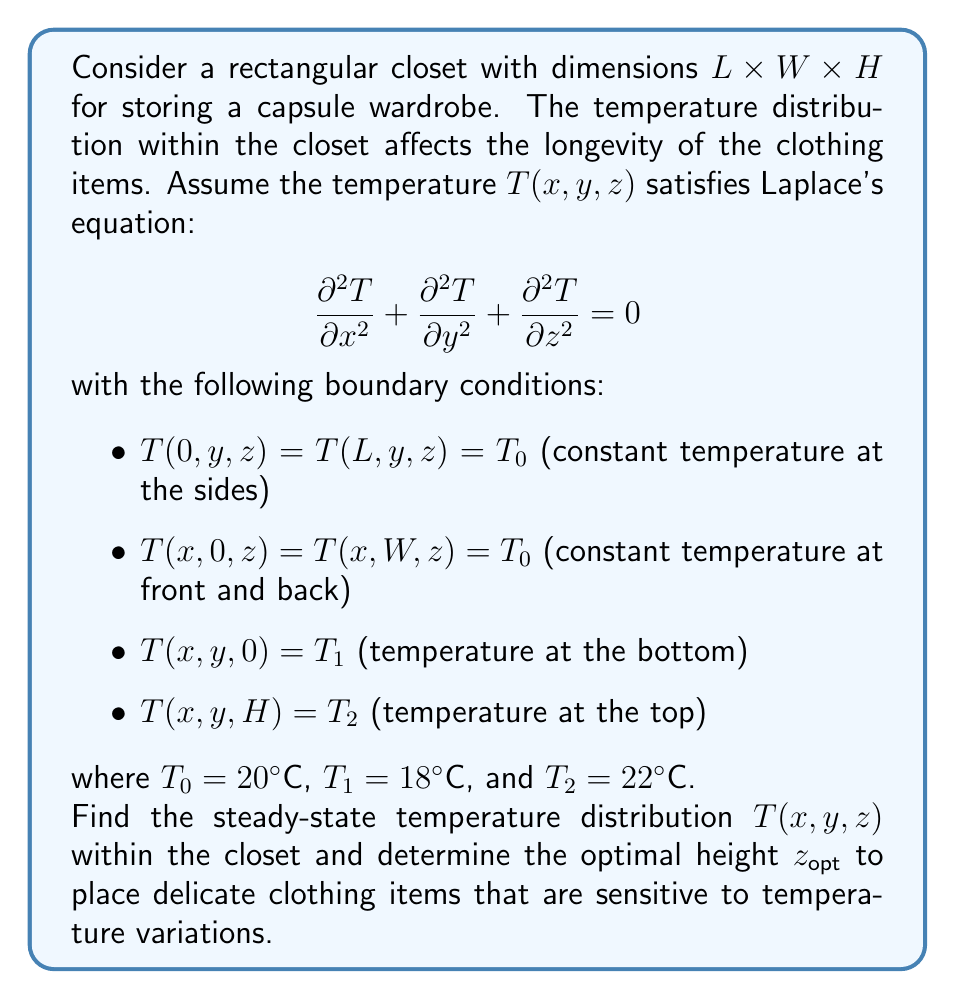Give your solution to this math problem. To solve this problem, we'll follow these steps:

1) The general solution to Laplace's equation in 3D rectangular coordinates is:

   $$T(x,y,z) = \sum_{m=1}^{\infty} \sum_{n=1}^{\infty} [A_{mn} \sinh(\lambda_{mn}z) + B_{mn} \cosh(\lambda_{mn}z)] \sin(\frac{m\pi x}{L}) \sin(\frac{n\pi y}{W})$$

   where $\lambda_{mn} = \pi \sqrt{(\frac{m}{L})^2 + (\frac{n}{W})^2}$

2) The boundary conditions at $x=0$, $x=L$, $y=0$, and $y=W$ are already satisfied by this general solution.

3) To satisfy the boundary conditions at $z=0$ and $z=H$, we need:

   $$T(x,y,0) = T_1 = \sum_{m=1}^{\infty} \sum_{n=1}^{\infty} B_{mn} \sin(\frac{m\pi x}{L}) \sin(\frac{n\pi y}{W})$$

   $$T(x,y,H) = T_2 = \sum_{m=1}^{\infty} \sum_{n=1}^{\infty} [A_{mn} \sinh(\lambda_{mn}H) + B_{mn} \cosh(\lambda_{mn}H)] \sin(\frac{m\pi x}{L}) \sin(\frac{n\pi y}{W})$$

4) Subtracting these equations:

   $$T_2 - T_1 = \sum_{m=1}^{\infty} \sum_{n=1}^{\infty} A_{mn} \sinh(\lambda_{mn}H) \sin(\frac{m\pi x}{L}) \sin(\frac{n\pi y}{W})$$

5) This implies:

   $$A_{mn} = \frac{T_2 - T_1}{\sinh(\lambda_{mn}H)}$$

   $$B_{mn} = \frac{T_1 \sinh(\lambda_{mn}H) - T_2 \sinh(\lambda_{mn}(H-z))}{\sinh(\lambda_{mn}H)}$$

6) Therefore, the temperature distribution is:

   $$T(x,y,z) = T_1 + (T_2 - T_1) \frac{\sinh(\lambda_{mn}z)}{\sinh(\lambda_{mn}H)}$$

7) To find the optimal height for delicate items, we need to find where the temperature gradient is minimal. The gradient is:

   $$\frac{\partial T}{\partial z} = (T_2 - T_1) \frac{\lambda_{mn} \cosh(\lambda_{mn}z)}{\sinh(\lambda_{mn}H)}$$

8) This gradient is zero at $z = H/2$, which is the midpoint of the closet height.

Therefore, the optimal height to place delicate clothing items is at $z_{opt} = H/2$.
Answer: The steady-state temperature distribution within the closet is:

$$T(x,y,z) = T_1 + (T_2 - T_1) \frac{\sinh(\lambda_{mn}z)}{\sinh(\lambda_{mn}H)}$$

The optimal height to place delicate clothing items is $z_{opt} = H/2$, which is the midpoint of the closet height. 